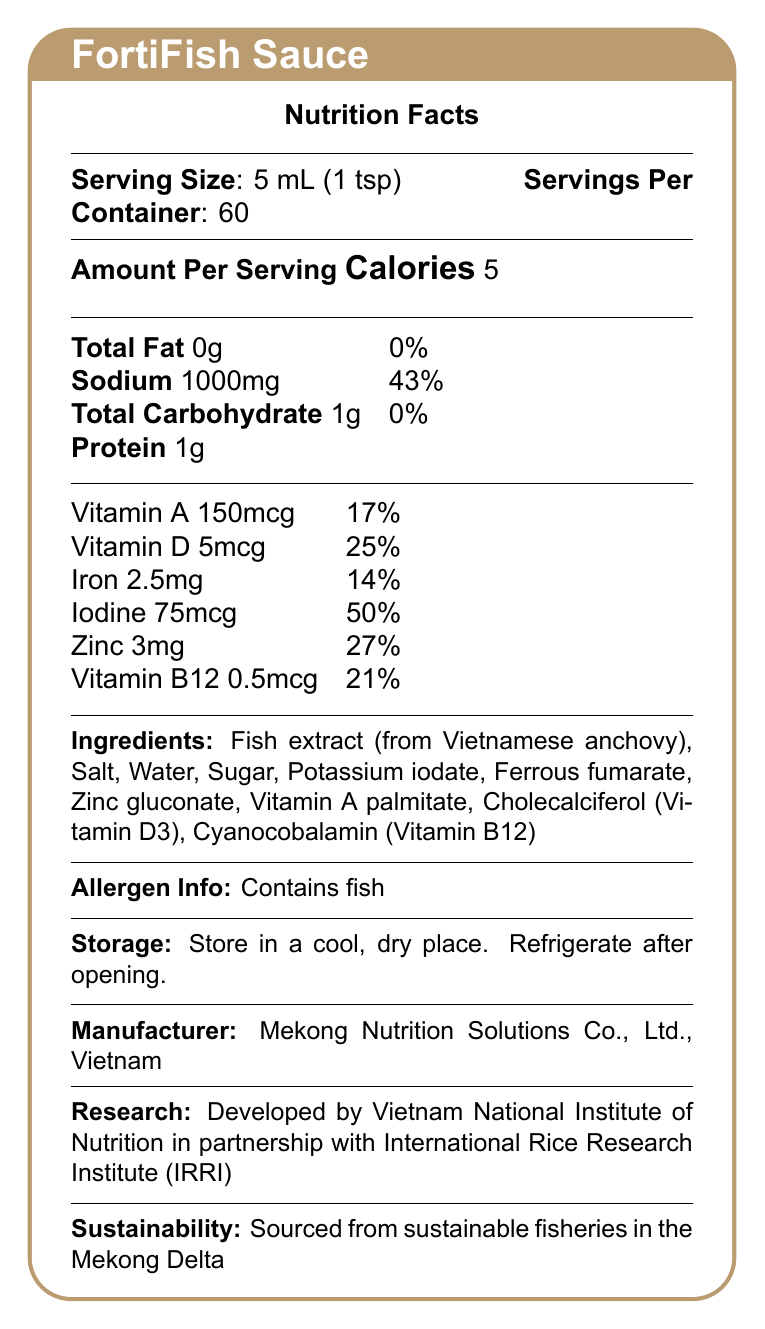What is the serving size of FortiFish Sauce? The document states the serving size as 5 mL (1 tsp).
Answer: 5 mL (1 tsp) How many servings are there per container of FortiFish Sauce? The document specifies that there are 60 servings per container.
Answer: 60 How many calories are there per serving of FortiFish Sauce? The document states that each serving contains 5 calories.
Answer: 5 Does FortiFish Sauce contain protein? If yes, how much? The document lists protein amount per serving as 1g.
Answer: Yes, 1g What percentage of the daily value for sodium does one serving of FortiFish Sauce provide? The sodium content per serving is given as 1000mg, which is 43% of the daily value.
Answer: 43% Which vitamin in FortiFish Sauce has the highest percentage of daily value per serving? A. Vitamin A B. Vitamin D C. Vitamin B12 D. Iodine Iodine has a daily value of 50% per serving, which is the highest among the listed vitamins and minerals.
Answer: D. Iodine How much Vitamin D is there in a serving of FortiFish Sauce? A. 2mcg B. 5mcg C. 17mcg D. 21mcg The document lists 5mcg of Vitamin D per serving.
Answer: B. 5mcg Is the FortiFish Sauce designed to support thyroid function? The document highlights iodine as one of the ingredients that support thyroid function.
Answer: Yes Can FortiFish Sauce help address iron deficiency anemia? The key benefits section mentions that the product addresses iron deficiency anemia.
Answer: Yes Where is the FortiFish Sauce manufactured? The document specifies that it is manufactured by Mekong Nutrition Solutions Co., Ltd. in Vietnam.
Answer: Vietnam Who collaborated with Vietnam National Institute of Nutrition to develop FortiFish Sauce? The research and development section indicates a partnership with IRRI.
Answer: International Rice Research Institute (IRRI) What are the main benefits of FortiFish Sauce? The document lists these as the key benefits.
Answer: Addresses iron deficiency anemia, supports thyroid function with iodine, enhances immune system with zinc and vitamin A, promotes bone health with vitamin D, supports cognitive function with vitamin B12. Is FortiFish Sauce approved by any regulatory body? The document states it is approved by the Vietnam Food Administration.
Answer: Yes Does FortiFish Sauce contain any allergens? The allergen information specifies it contains fish.
Answer: Yes Summarize the FortiFish Sauce document. This summary covers the main points including the purpose, nutritional content, benefits, collaboration, and approval details of the product.
Answer: FortiFish Sauce is a fortified fish sauce designed to address micronutrient deficiencies in rural populations, specifically targeting those in Southeast Asia. Each 5 mL serving contains essential vitamins and minerals such as Vitamin A, D, iron, iodine, zinc, and Vitamin B12. The product is developed by Vietnam National Institute of Nutrition in collaboration with IRRI, manufactured by Mekong Nutrition Solutions Co., Ltd., and approved by the Vietnam Food Administration. It supports various health benefits including addressing iron deficiency anemia, enhancing immune function, and promoting bone health. Ingredients include fish extract, various vitamins, and minerals, and it is sourced from sustainable fisheries in the Mekong Delta. How long can FortiFish Sauce be stored before it needs refrigeration? The document states to "refrigerate after opening" but does not specify how long it can be stored before this.
Answer: Not enough information What ingredient provides Vitamin D in FortiFish Sauce? The ingredient list identifies Cholecalciferol (Vitamin D3) as the source of Vitamin D.
Answer: Cholecalciferol (Vitamin D3) Is the FortiFish Sauce suitable for vegetarians? The document lists fish extract as an ingredient, indicating it is not suitable for vegetarians.
Answer: No 